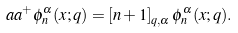Convert formula to latex. <formula><loc_0><loc_0><loc_500><loc_500>a a ^ { + } \phi _ { n } ^ { \alpha } ( x ; q ) = \left [ n + 1 \right ] _ { q , \alpha } \phi _ { n } ^ { \alpha } ( x ; q ) .</formula> 